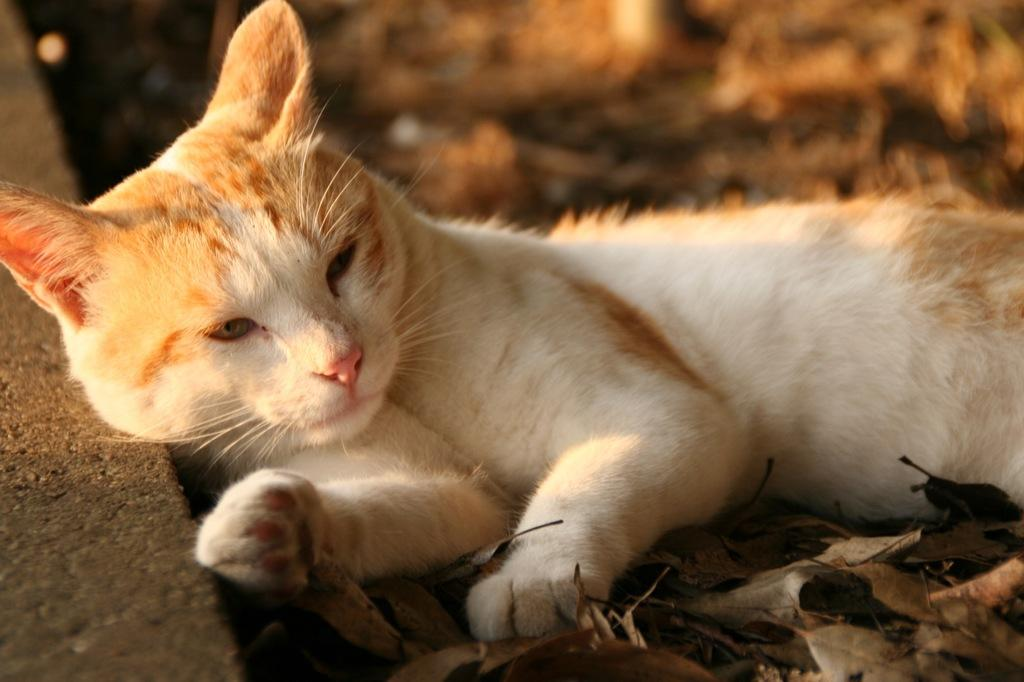What animal can be seen lying on a path in the image? There is a cat lying on a path in the image. What type of natural debris is visible in the image? There are dry leaves visible in the bottom right of the image. Can you describe the background of the image? The background of the image is blurry. What type of thought can be seen floating in the air in the image? There is no thought visible in the image; it is a photograph of a cat lying on a path with dry leaves in the background. 